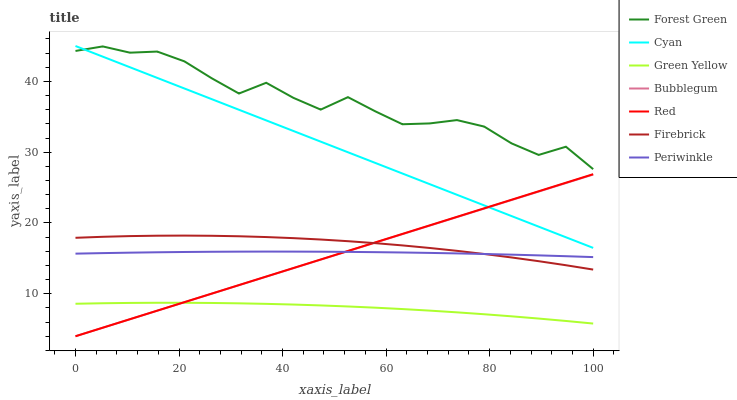Does Bubblegum have the minimum area under the curve?
Answer yes or no. No. Does Bubblegum have the maximum area under the curve?
Answer yes or no. No. Is Forest Green the smoothest?
Answer yes or no. No. Is Bubblegum the roughest?
Answer yes or no. No. Does Forest Green have the lowest value?
Answer yes or no. No. Does Bubblegum have the highest value?
Answer yes or no. No. Is Bubblegum less than Forest Green?
Answer yes or no. Yes. Is Firebrick greater than Green Yellow?
Answer yes or no. Yes. Does Bubblegum intersect Forest Green?
Answer yes or no. No. 